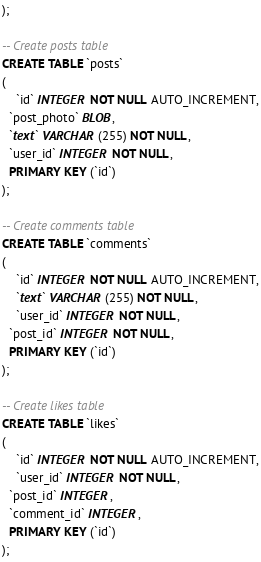Convert code to text. <code><loc_0><loc_0><loc_500><loc_500><_SQL_>);

-- Create posts table
CREATE TABLE `posts`
(
	`id` INTEGER NOT NULL AUTO_INCREMENT,
  `post_photo` BLOB,
  `text` VARCHAR (255) NOT NULL,
  `user_id` INTEGER NOT NULL,
  PRIMARY KEY (`id`)
);

-- Create comments table
CREATE TABLE `comments`
(
	`id` INTEGER NOT NULL AUTO_INCREMENT,
	`text` VARCHAR (255) NOT NULL,
	`user_id` INTEGER NOT NULL,
  `post_id` INTEGER NOT NULL,
  PRIMARY KEY (`id`)
);

-- Create likes table
CREATE TABLE `likes`
(
	`id` INTEGER NOT NULL AUTO_INCREMENT,
	`user_id` INTEGER NOT NULL,
  `post_id` INTEGER,
  `comment_id` INTEGER,
  PRIMARY KEY (`id`)
);</code> 